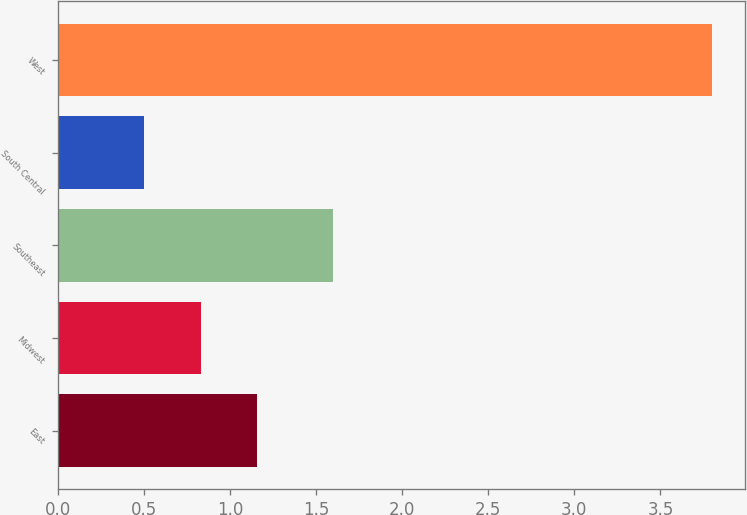<chart> <loc_0><loc_0><loc_500><loc_500><bar_chart><fcel>East<fcel>Midwest<fcel>Southeast<fcel>South Central<fcel>West<nl><fcel>1.16<fcel>0.83<fcel>1.6<fcel>0.5<fcel>3.8<nl></chart> 